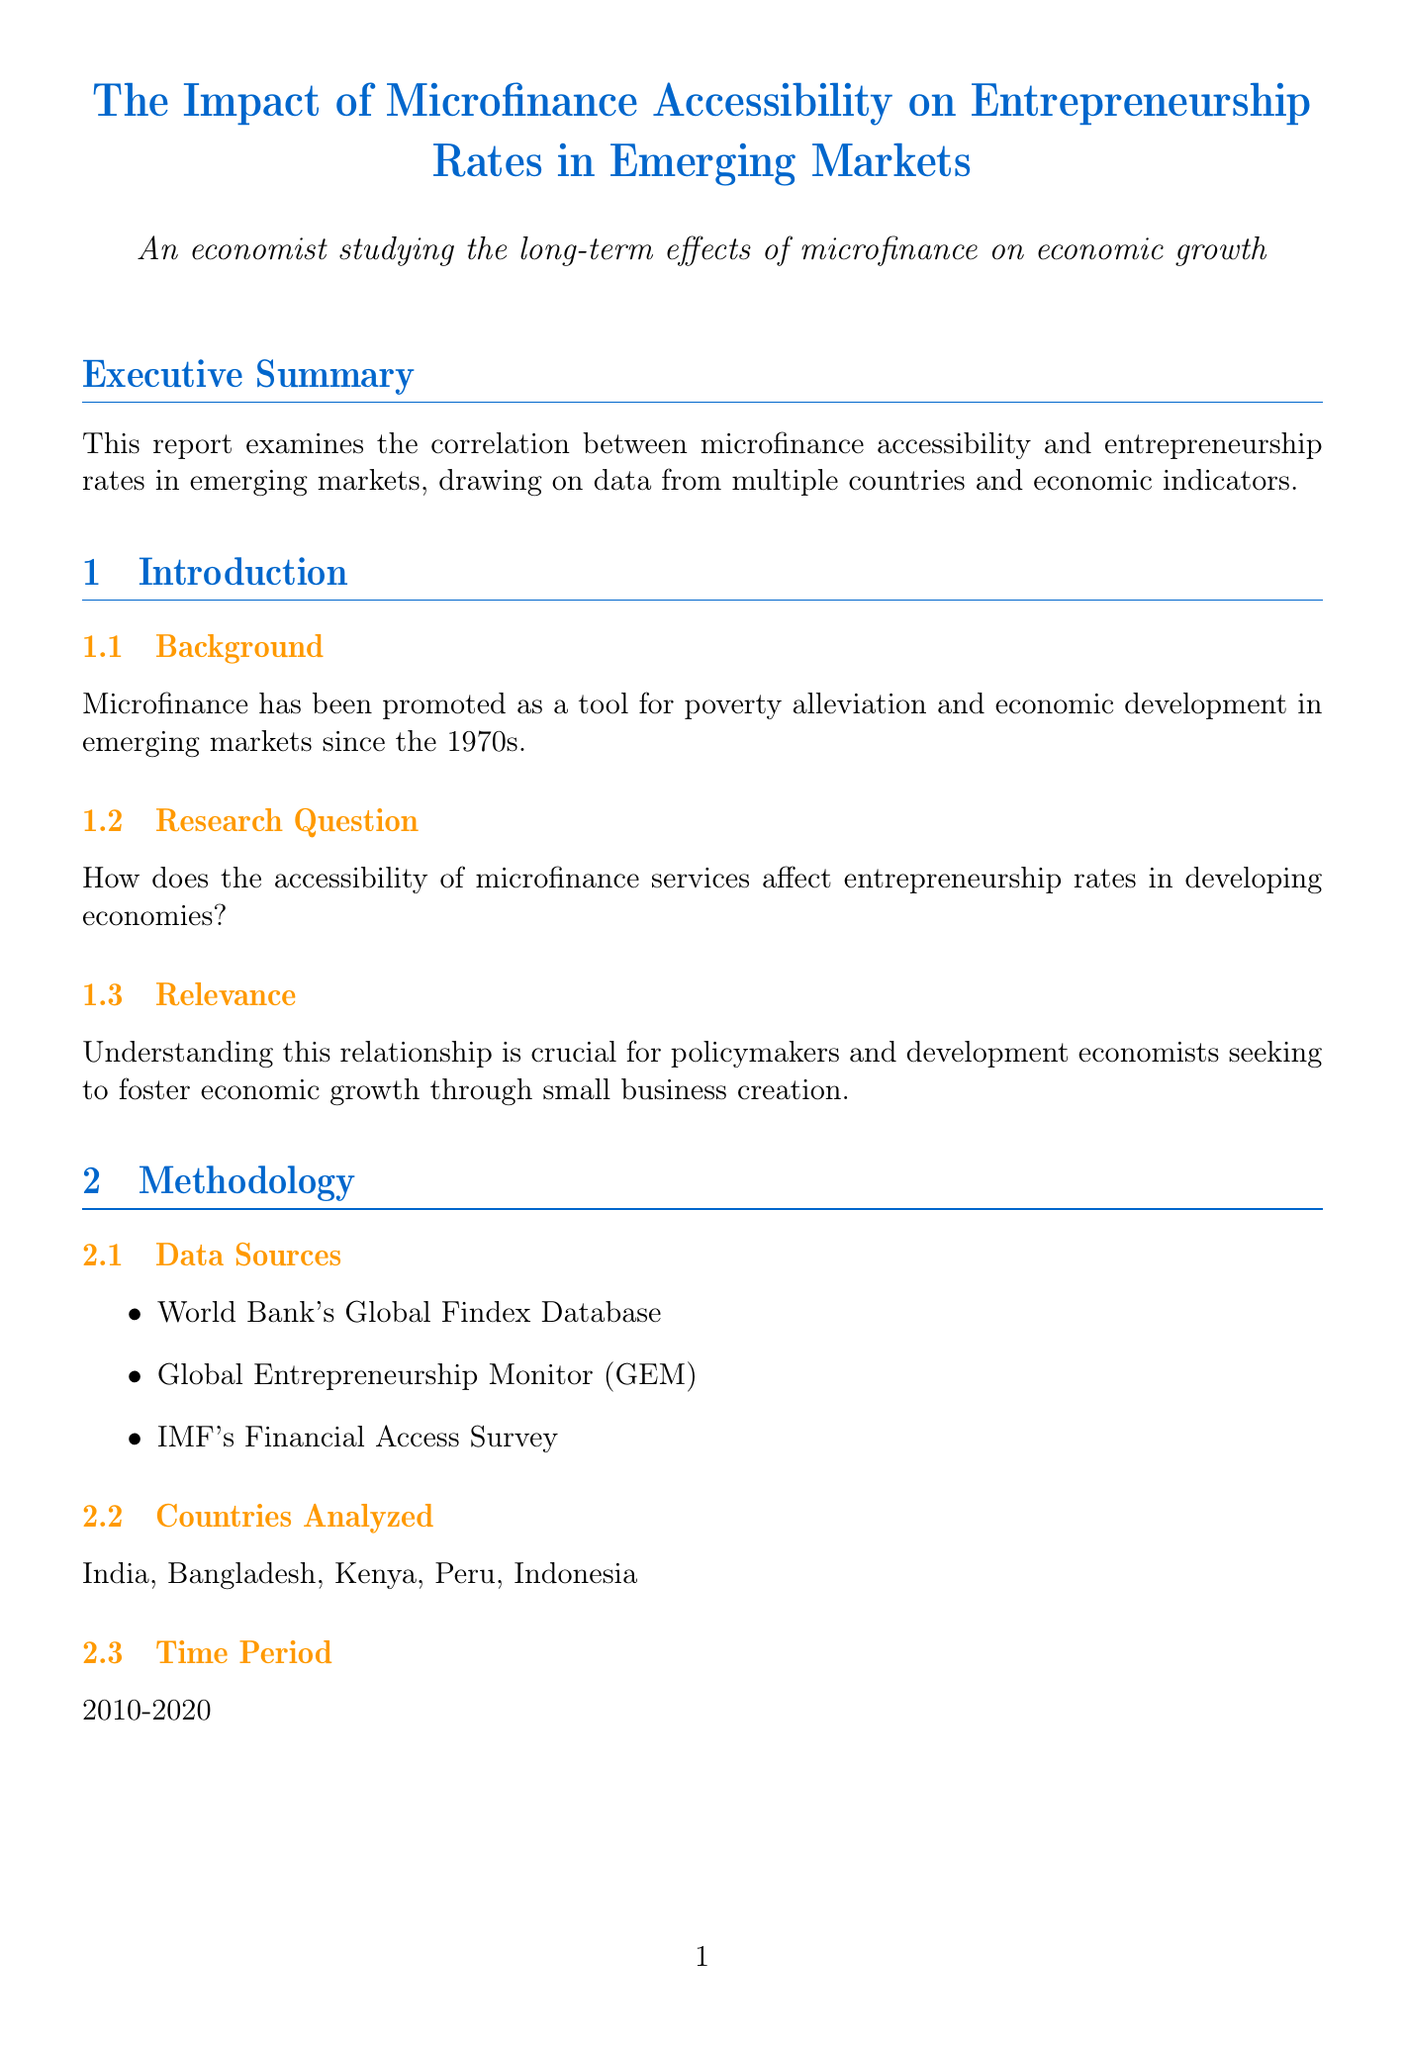What is the title of the report? The title of the report is found in the first section and indicates the main topic of discussion.
Answer: The Impact of Microfinance Accessibility on Entrepreneurship Rates in Emerging Markets How many countries were analyzed in the report? The report lists the specific countries that were analyzed in the Methodology section.
Answer: Five What is the time period covered by the study? The time period is mentioned in the Methodology section and indicates the years for which data was considered.
Answer: 2010-2020 What percentage increase in new business formation rates is associated with a 10% increase in microfinance accessibility? The key findings section provides specific statistics regarding the correlation between accessibility and business formation.
Answer: 3.5% Which institution's expansion correlated with a 7.2% increase in rural entrepreneurship rates in Bangladesh? The case study section includes information about significant institutions linked to microfinance impacts.
Answer: Grameen Bank What was the impact of MiBanco in Peru on urban microenterprise formation? The case study section highlights the results of specific institutions in various countries, indicating their positive effects.
Answer: 5.8% What specific sectors showed the strongest impact from microfinance accessibility? The key findings state the sectors where microfinance had the most pronounced effects.
Answer: Agriculture and small-scale manufacturing What type of analysis was used to explore the data? The methodology section lists the statistical methods employed for data analysis.
Answer: Multiple regression analysis 